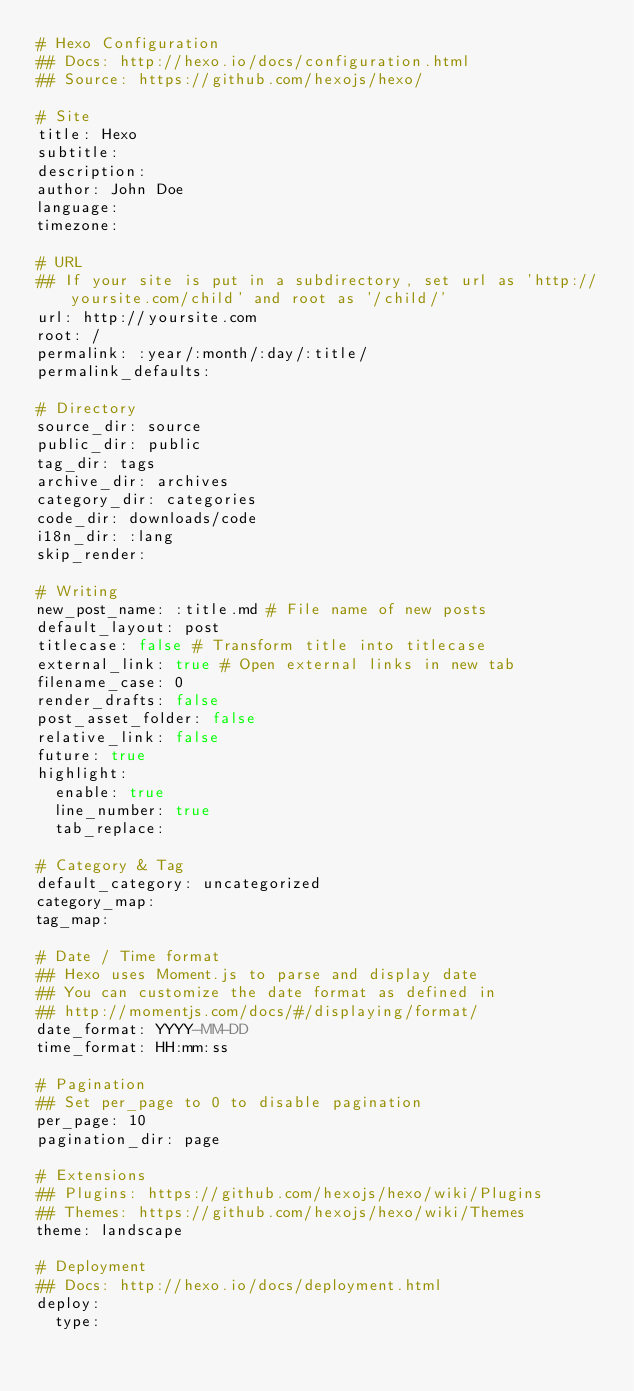Convert code to text. <code><loc_0><loc_0><loc_500><loc_500><_YAML_># Hexo Configuration
## Docs: http://hexo.io/docs/configuration.html
## Source: https://github.com/hexojs/hexo/

# Site
title: Hexo
subtitle:
description:
author: John Doe
language:
timezone:

# URL
## If your site is put in a subdirectory, set url as 'http://yoursite.com/child' and root as '/child/'
url: http://yoursite.com
root: /
permalink: :year/:month/:day/:title/
permalink_defaults:

# Directory
source_dir: source
public_dir: public
tag_dir: tags
archive_dir: archives
category_dir: categories
code_dir: downloads/code
i18n_dir: :lang
skip_render:

# Writing
new_post_name: :title.md # File name of new posts
default_layout: post
titlecase: false # Transform title into titlecase
external_link: true # Open external links in new tab
filename_case: 0
render_drafts: false
post_asset_folder: false
relative_link: false
future: true
highlight:
  enable: true
  line_number: true
  tab_replace:

# Category & Tag
default_category: uncategorized
category_map:
tag_map:

# Date / Time format
## Hexo uses Moment.js to parse and display date
## You can customize the date format as defined in
## http://momentjs.com/docs/#/displaying/format/
date_format: YYYY-MM-DD
time_format: HH:mm:ss

# Pagination
## Set per_page to 0 to disable pagination
per_page: 10
pagination_dir: page

# Extensions
## Plugins: https://github.com/hexojs/hexo/wiki/Plugins
## Themes: https://github.com/hexojs/hexo/wiki/Themes
theme: landscape

# Deployment
## Docs: http://hexo.io/docs/deployment.html
deploy:
  type:</code> 